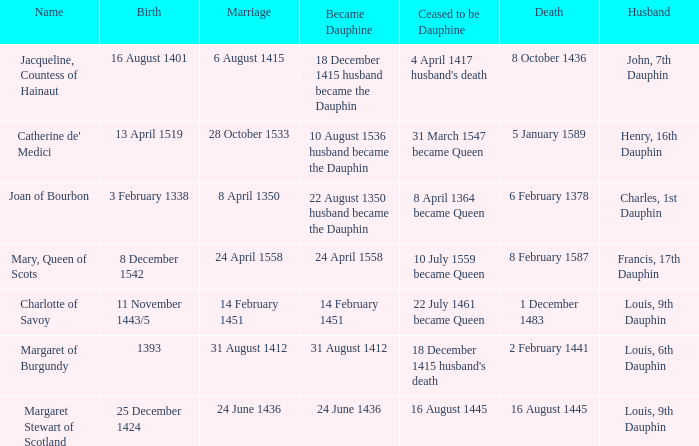When was became dauphine when birth is 1393? 31 August 1412. 